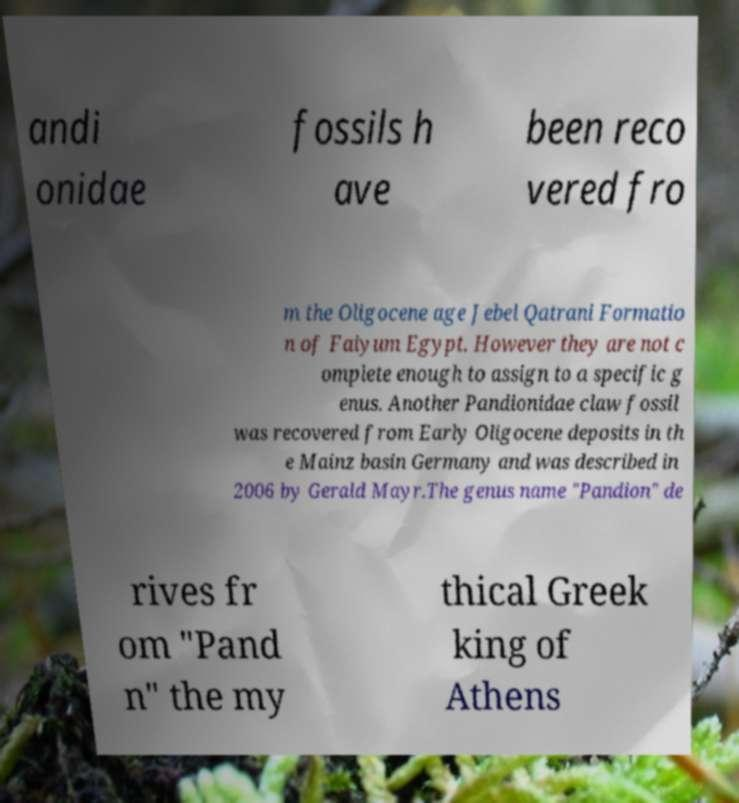Please read and relay the text visible in this image. What does it say? andi onidae fossils h ave been reco vered fro m the Oligocene age Jebel Qatrani Formatio n of Faiyum Egypt. However they are not c omplete enough to assign to a specific g enus. Another Pandionidae claw fossil was recovered from Early Oligocene deposits in th e Mainz basin Germany and was described in 2006 by Gerald Mayr.The genus name "Pandion" de rives fr om "Pand n" the my thical Greek king of Athens 